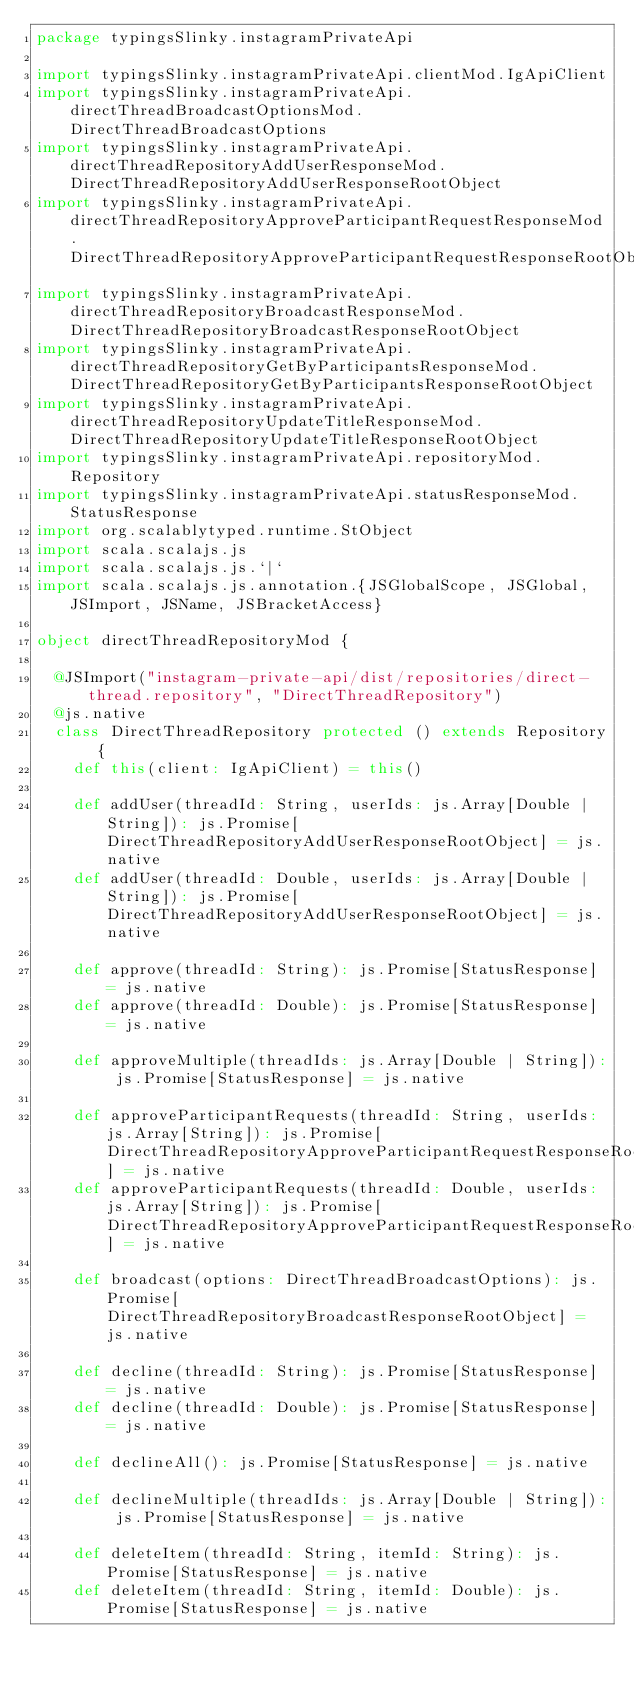<code> <loc_0><loc_0><loc_500><loc_500><_Scala_>package typingsSlinky.instagramPrivateApi

import typingsSlinky.instagramPrivateApi.clientMod.IgApiClient
import typingsSlinky.instagramPrivateApi.directThreadBroadcastOptionsMod.DirectThreadBroadcastOptions
import typingsSlinky.instagramPrivateApi.directThreadRepositoryAddUserResponseMod.DirectThreadRepositoryAddUserResponseRootObject
import typingsSlinky.instagramPrivateApi.directThreadRepositoryApproveParticipantRequestResponseMod.DirectThreadRepositoryApproveParticipantRequestResponseRootObject
import typingsSlinky.instagramPrivateApi.directThreadRepositoryBroadcastResponseMod.DirectThreadRepositoryBroadcastResponseRootObject
import typingsSlinky.instagramPrivateApi.directThreadRepositoryGetByParticipantsResponseMod.DirectThreadRepositoryGetByParticipantsResponseRootObject
import typingsSlinky.instagramPrivateApi.directThreadRepositoryUpdateTitleResponseMod.DirectThreadRepositoryUpdateTitleResponseRootObject
import typingsSlinky.instagramPrivateApi.repositoryMod.Repository
import typingsSlinky.instagramPrivateApi.statusResponseMod.StatusResponse
import org.scalablytyped.runtime.StObject
import scala.scalajs.js
import scala.scalajs.js.`|`
import scala.scalajs.js.annotation.{JSGlobalScope, JSGlobal, JSImport, JSName, JSBracketAccess}

object directThreadRepositoryMod {
  
  @JSImport("instagram-private-api/dist/repositories/direct-thread.repository", "DirectThreadRepository")
  @js.native
  class DirectThreadRepository protected () extends Repository {
    def this(client: IgApiClient) = this()
    
    def addUser(threadId: String, userIds: js.Array[Double | String]): js.Promise[DirectThreadRepositoryAddUserResponseRootObject] = js.native
    def addUser(threadId: Double, userIds: js.Array[Double | String]): js.Promise[DirectThreadRepositoryAddUserResponseRootObject] = js.native
    
    def approve(threadId: String): js.Promise[StatusResponse] = js.native
    def approve(threadId: Double): js.Promise[StatusResponse] = js.native
    
    def approveMultiple(threadIds: js.Array[Double | String]): js.Promise[StatusResponse] = js.native
    
    def approveParticipantRequests(threadId: String, userIds: js.Array[String]): js.Promise[DirectThreadRepositoryApproveParticipantRequestResponseRootObject] = js.native
    def approveParticipantRequests(threadId: Double, userIds: js.Array[String]): js.Promise[DirectThreadRepositoryApproveParticipantRequestResponseRootObject] = js.native
    
    def broadcast(options: DirectThreadBroadcastOptions): js.Promise[DirectThreadRepositoryBroadcastResponseRootObject] = js.native
    
    def decline(threadId: String): js.Promise[StatusResponse] = js.native
    def decline(threadId: Double): js.Promise[StatusResponse] = js.native
    
    def declineAll(): js.Promise[StatusResponse] = js.native
    
    def declineMultiple(threadIds: js.Array[Double | String]): js.Promise[StatusResponse] = js.native
    
    def deleteItem(threadId: String, itemId: String): js.Promise[StatusResponse] = js.native
    def deleteItem(threadId: String, itemId: Double): js.Promise[StatusResponse] = js.native</code> 